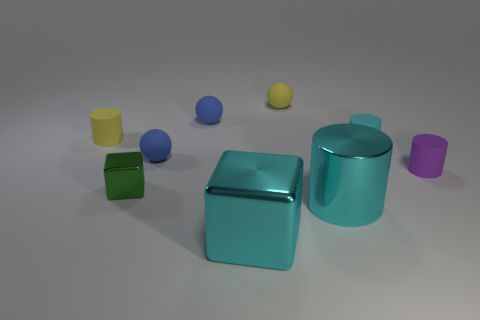There is a cyan metallic object that is to the left of the cyan shiny cylinder; does it have the same size as the small green metallic block?
Provide a succinct answer. No. Are there fewer yellow matte spheres than big cyan shiny things?
Ensure brevity in your answer.  Yes. There is a small yellow matte object that is left of the small object in front of the purple rubber thing behind the large cyan shiny cylinder; what shape is it?
Your response must be concise. Cylinder. Is there a cyan object made of the same material as the tiny purple cylinder?
Ensure brevity in your answer.  Yes. Does the cylinder that is left of the small green block have the same color as the thing in front of the large cyan metallic cylinder?
Your answer should be very brief. No. Is the number of purple cylinders in front of the small green cube less than the number of tiny green things?
Make the answer very short. Yes. How many objects are either tiny blocks or cylinders behind the green shiny thing?
Provide a succinct answer. 4. What is the color of the big cube that is the same material as the small cube?
Make the answer very short. Cyan. What number of objects are big green shiny objects or small yellow matte objects?
Give a very brief answer. 2. What color is the shiny block that is the same size as the purple rubber object?
Your response must be concise. Green. 